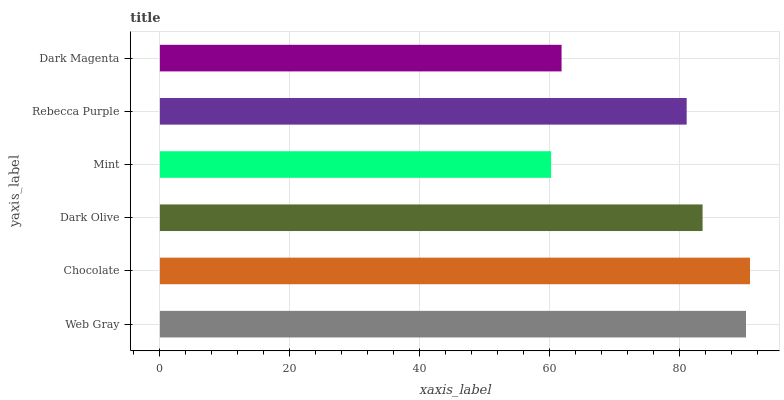Is Mint the minimum?
Answer yes or no. Yes. Is Chocolate the maximum?
Answer yes or no. Yes. Is Dark Olive the minimum?
Answer yes or no. No. Is Dark Olive the maximum?
Answer yes or no. No. Is Chocolate greater than Dark Olive?
Answer yes or no. Yes. Is Dark Olive less than Chocolate?
Answer yes or no. Yes. Is Dark Olive greater than Chocolate?
Answer yes or no. No. Is Chocolate less than Dark Olive?
Answer yes or no. No. Is Dark Olive the high median?
Answer yes or no. Yes. Is Rebecca Purple the low median?
Answer yes or no. Yes. Is Rebecca Purple the high median?
Answer yes or no. No. Is Dark Magenta the low median?
Answer yes or no. No. 